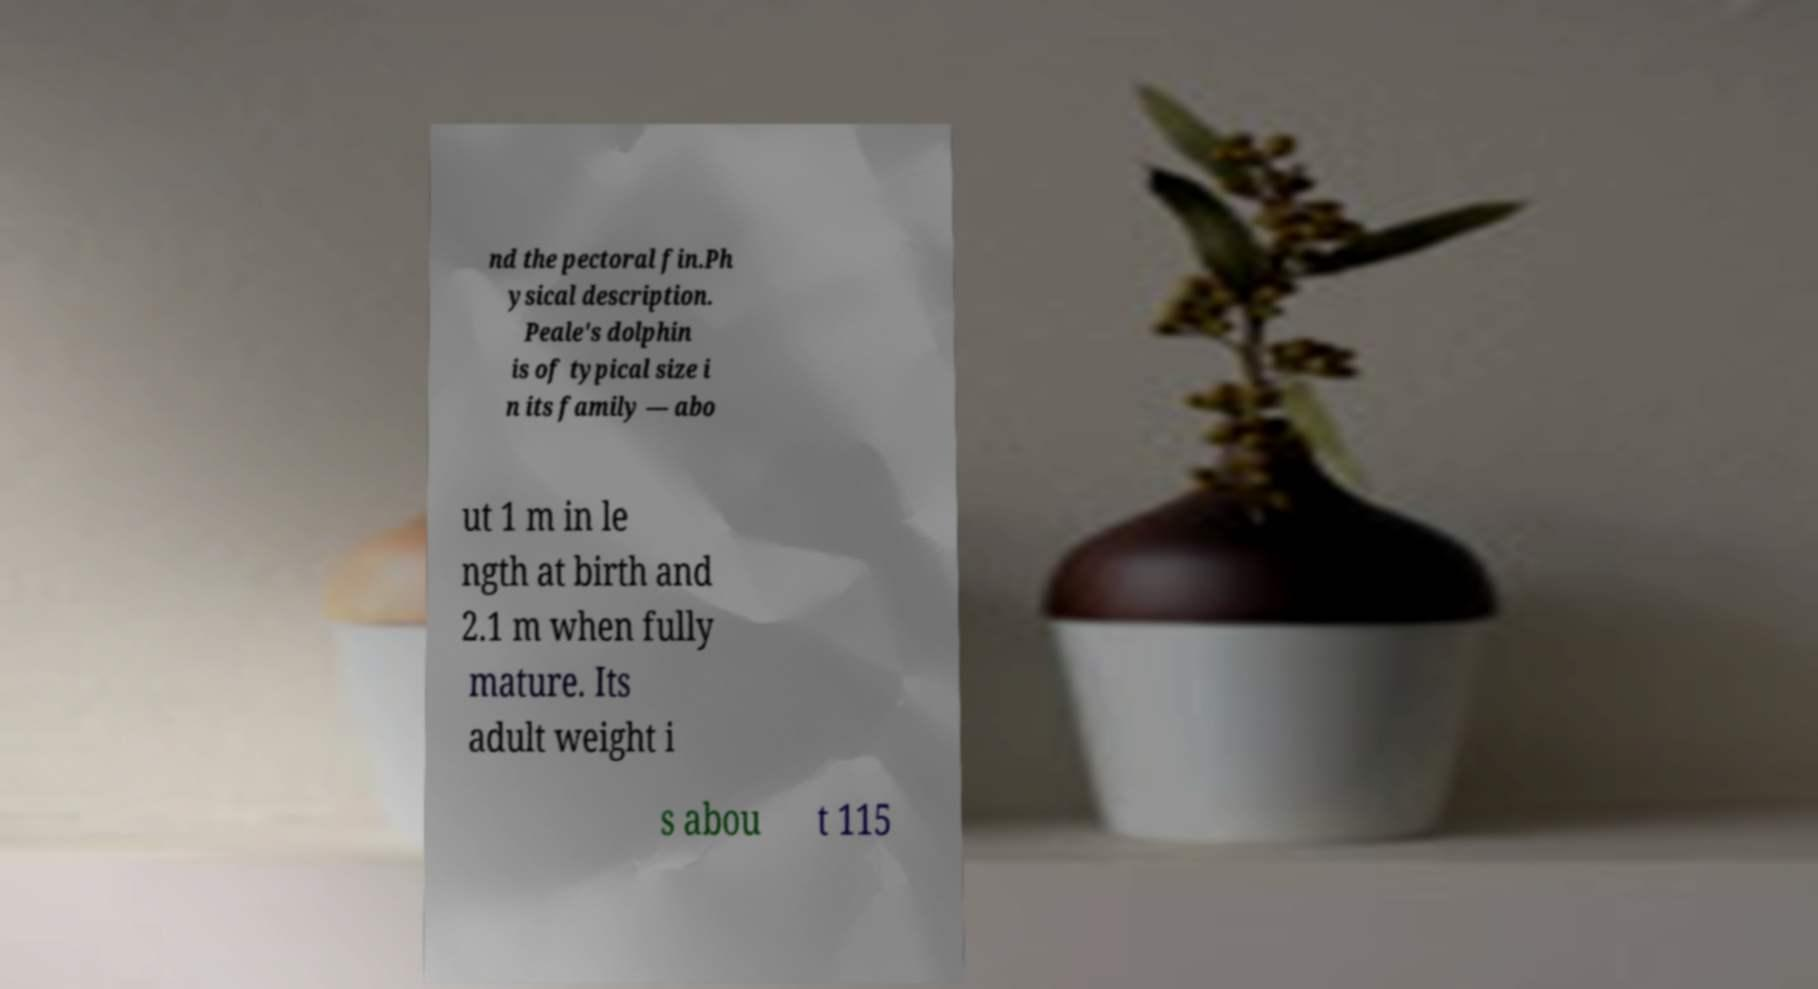What messages or text are displayed in this image? I need them in a readable, typed format. nd the pectoral fin.Ph ysical description. Peale's dolphin is of typical size i n its family — abo ut 1 m in le ngth at birth and 2.1 m when fully mature. Its adult weight i s abou t 115 